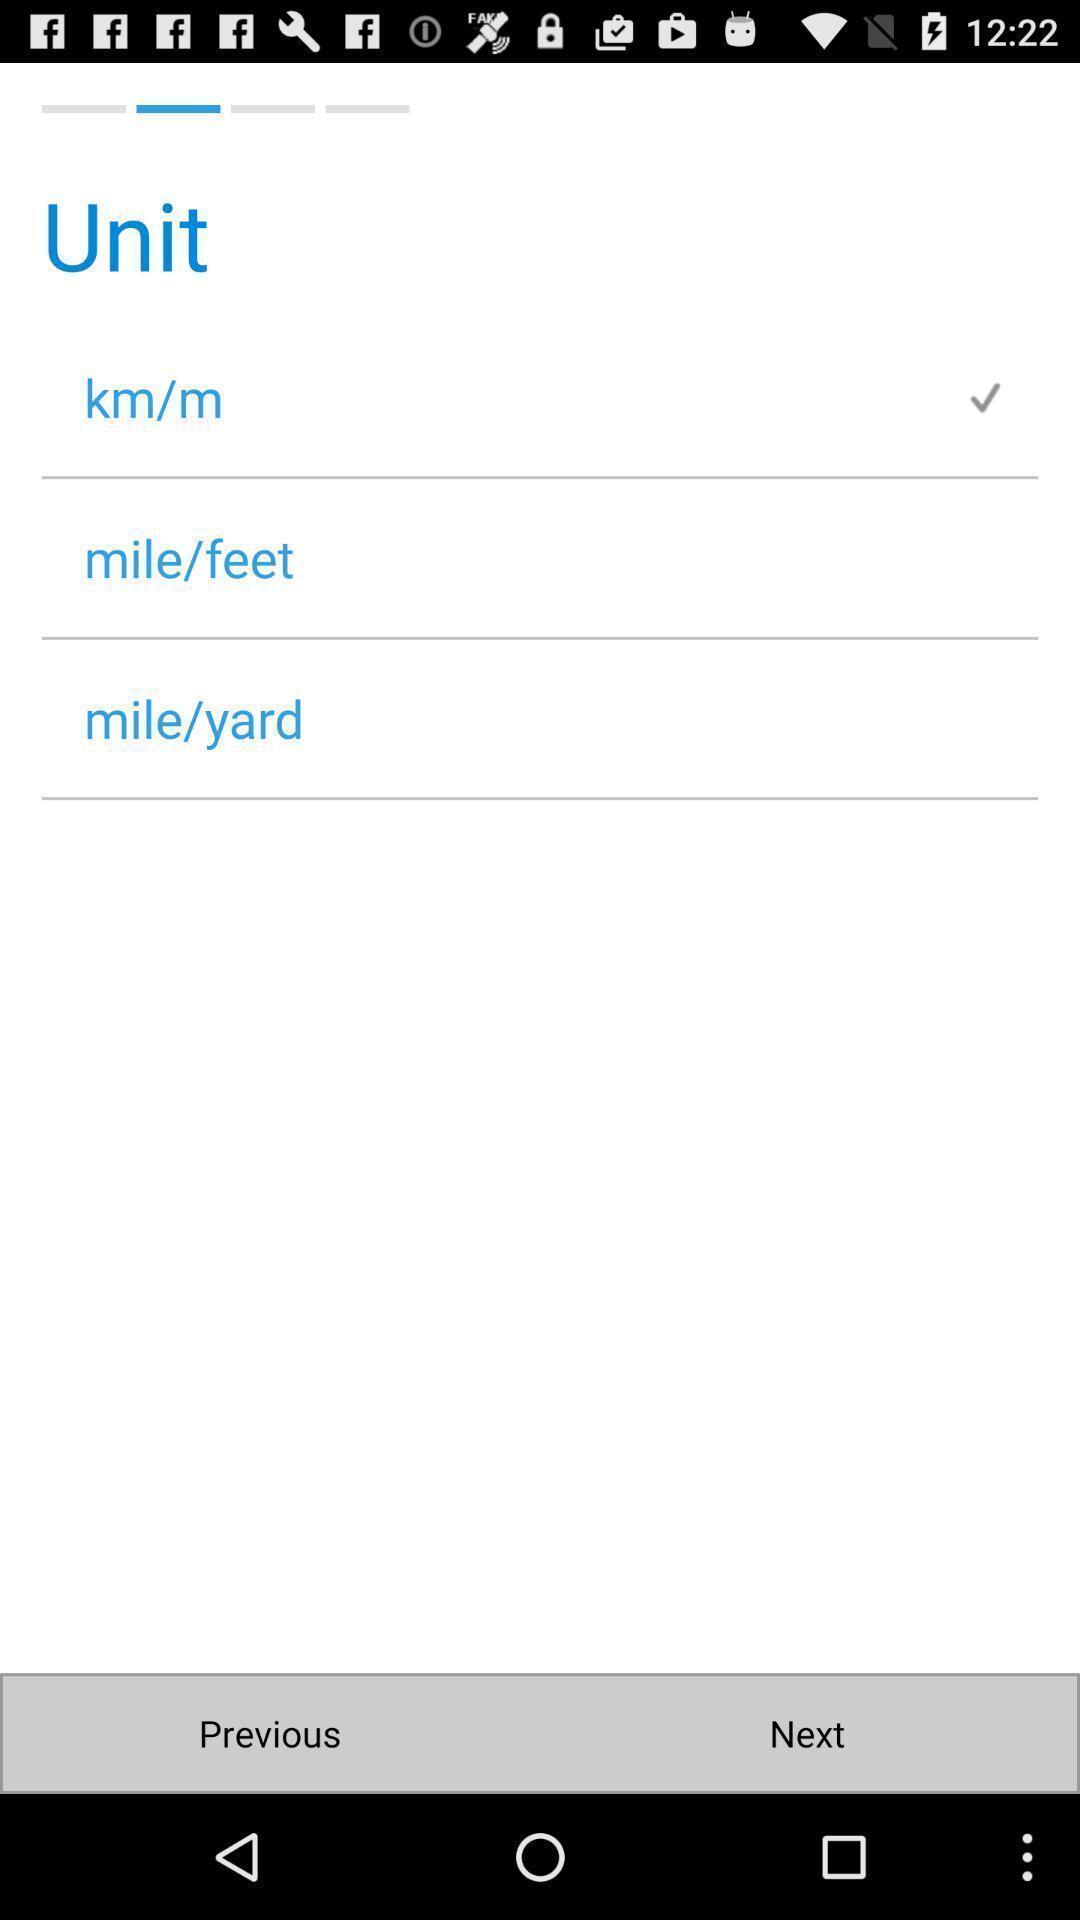Explain what's happening in this screen capture. Screen shows different options. 